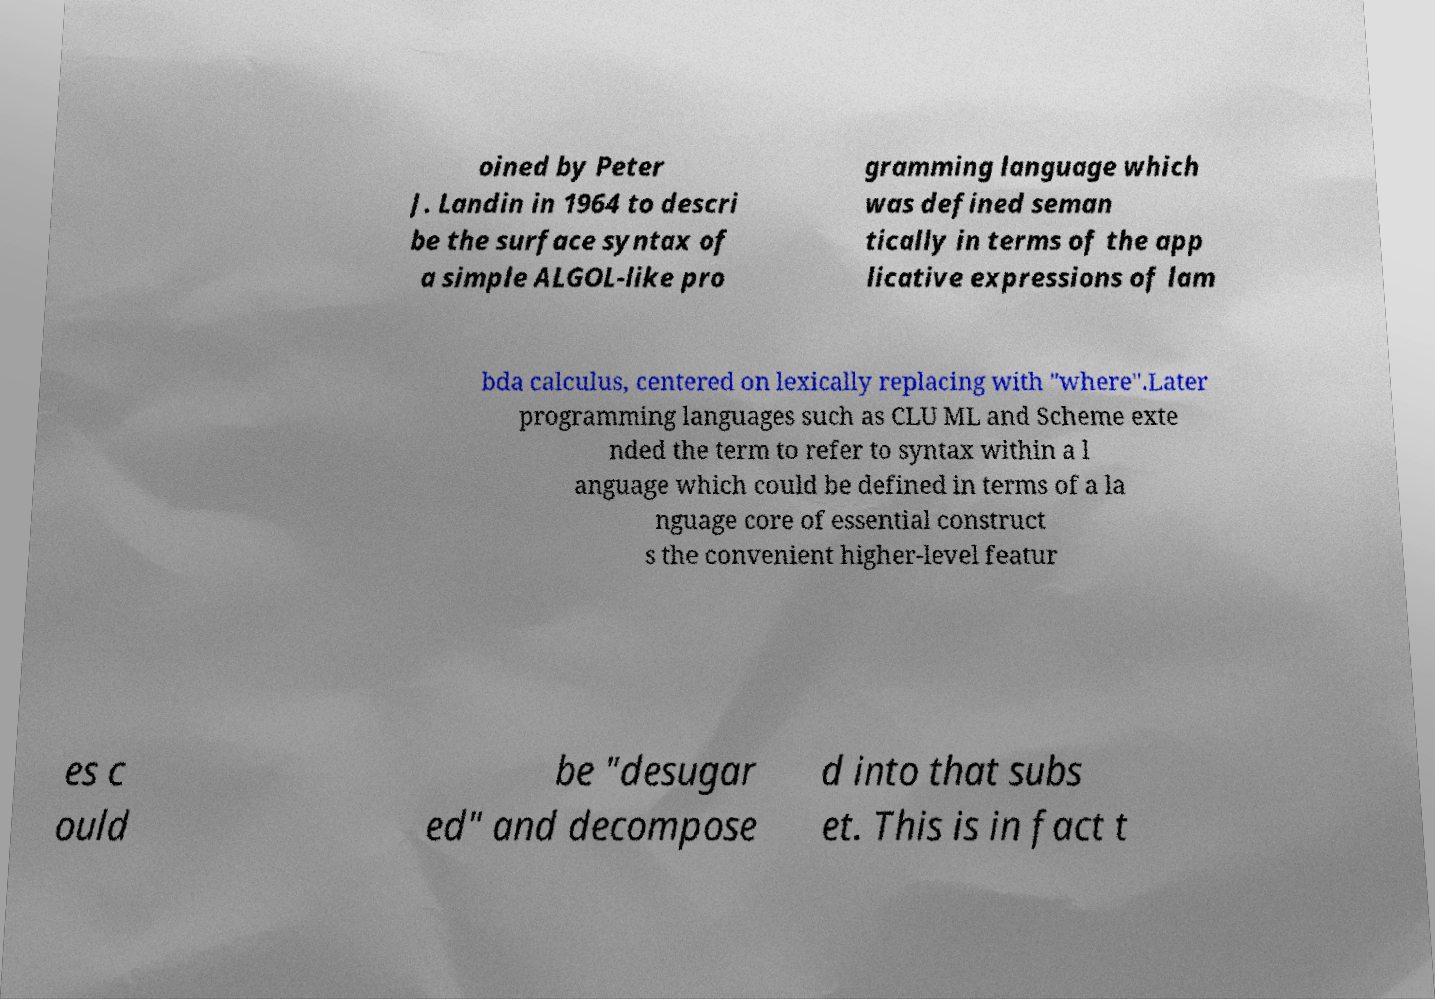There's text embedded in this image that I need extracted. Can you transcribe it verbatim? oined by Peter J. Landin in 1964 to descri be the surface syntax of a simple ALGOL-like pro gramming language which was defined seman tically in terms of the app licative expressions of lam bda calculus, centered on lexically replacing with "where".Later programming languages such as CLU ML and Scheme exte nded the term to refer to syntax within a l anguage which could be defined in terms of a la nguage core of essential construct s the convenient higher-level featur es c ould be "desugar ed" and decompose d into that subs et. This is in fact t 